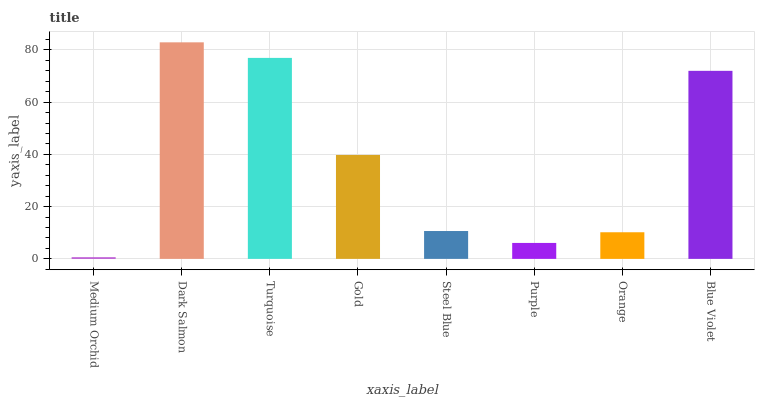Is Turquoise the minimum?
Answer yes or no. No. Is Turquoise the maximum?
Answer yes or no. No. Is Dark Salmon greater than Turquoise?
Answer yes or no. Yes. Is Turquoise less than Dark Salmon?
Answer yes or no. Yes. Is Turquoise greater than Dark Salmon?
Answer yes or no. No. Is Dark Salmon less than Turquoise?
Answer yes or no. No. Is Gold the high median?
Answer yes or no. Yes. Is Steel Blue the low median?
Answer yes or no. Yes. Is Purple the high median?
Answer yes or no. No. Is Dark Salmon the low median?
Answer yes or no. No. 